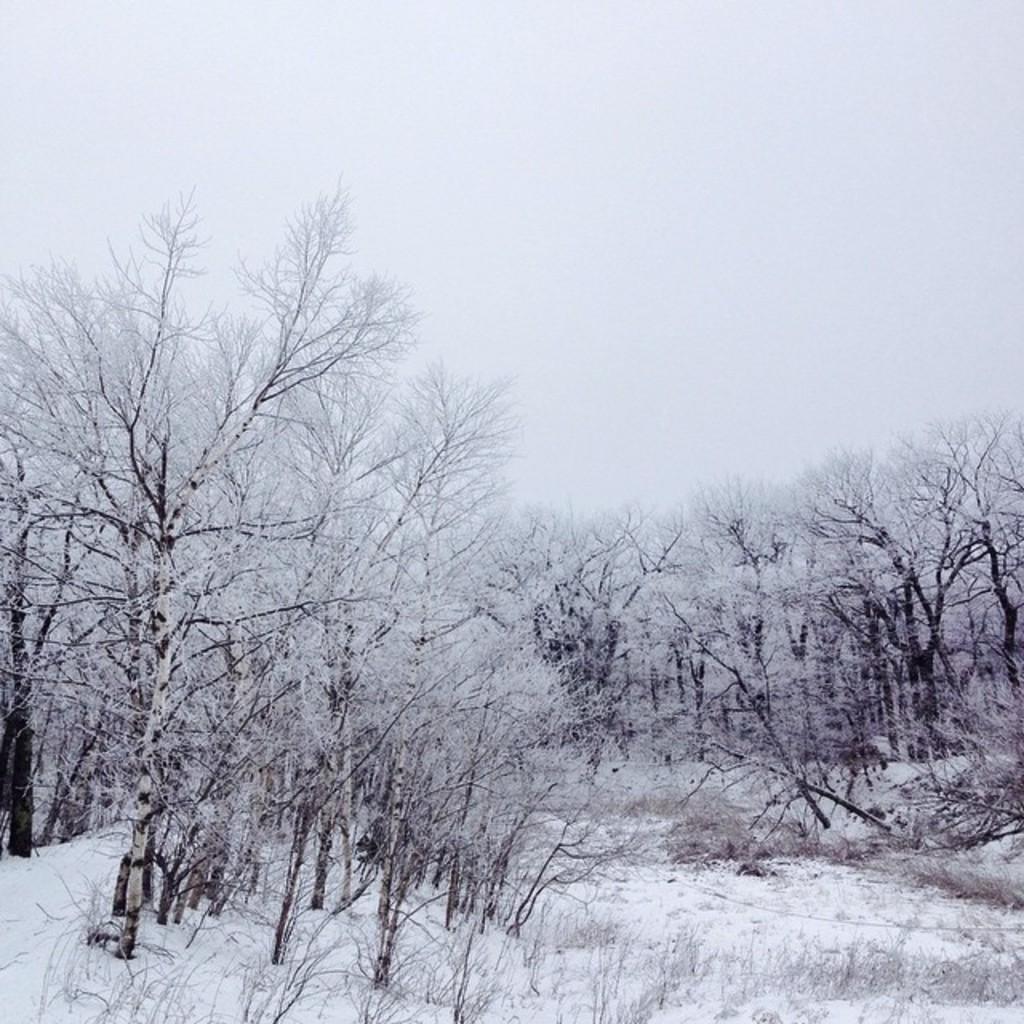Please provide a concise description of this image. In this picture we can see bare trees. This is snow. In the background there is sky. 